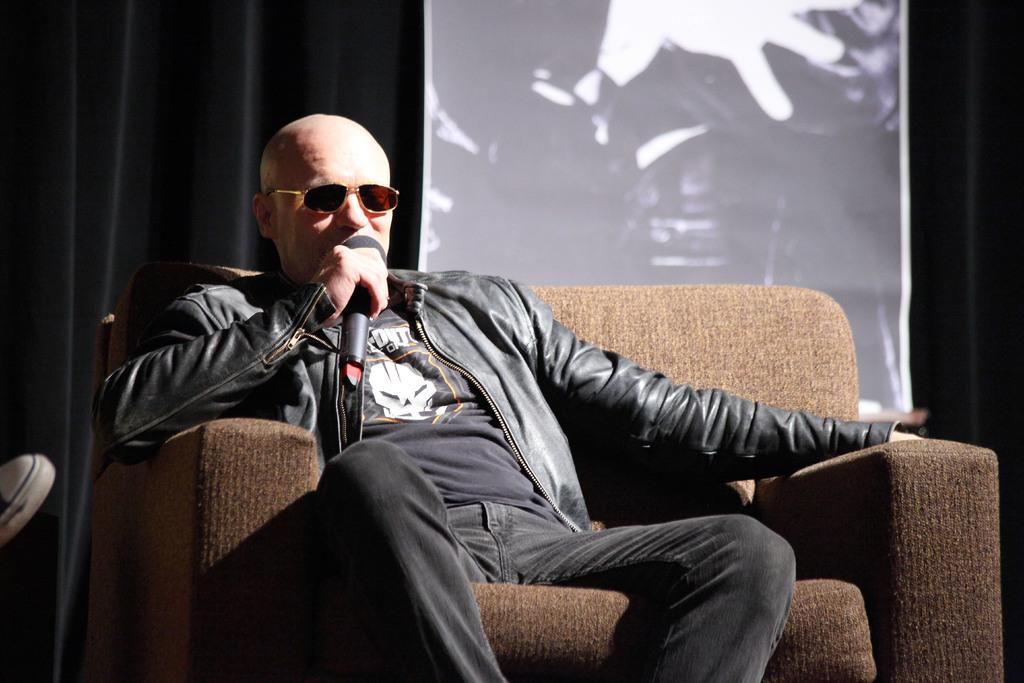What is the person in the image doing? The person is sitting on a chair. What is the person wearing? The person is wearing a jacket and goggles. What object is the person holding? The person is holding a mic. What can be seen in the background of the image? There is a black curtain and a screen in the background. What type of mist is visible around the person in the image? There is no mist visible around the person in the image. Is the person holding a crook in the image? No, the person is holding a mic, not a crook. 